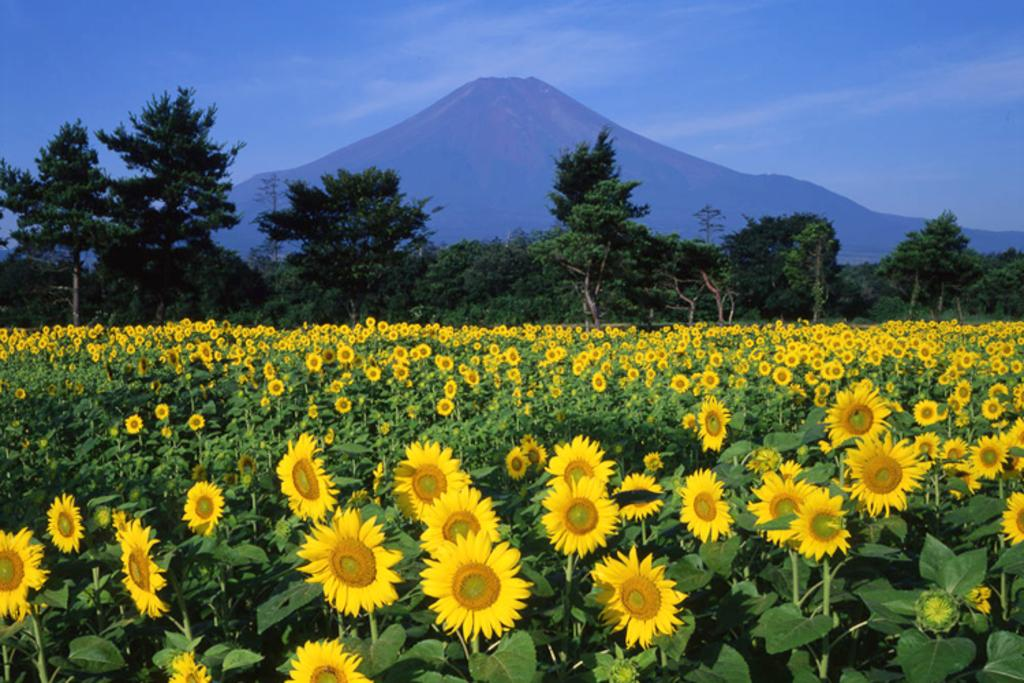What type of vegetation can be seen in the image? There are trees and sunflower plants in the image. What is visible in the background of the image? There is a hill and the sky visible in the background of the image. Can you hear the snake rustling through the grass in the image? There is no snake present in the image, so it is not possible to hear it rustling through the grass. 